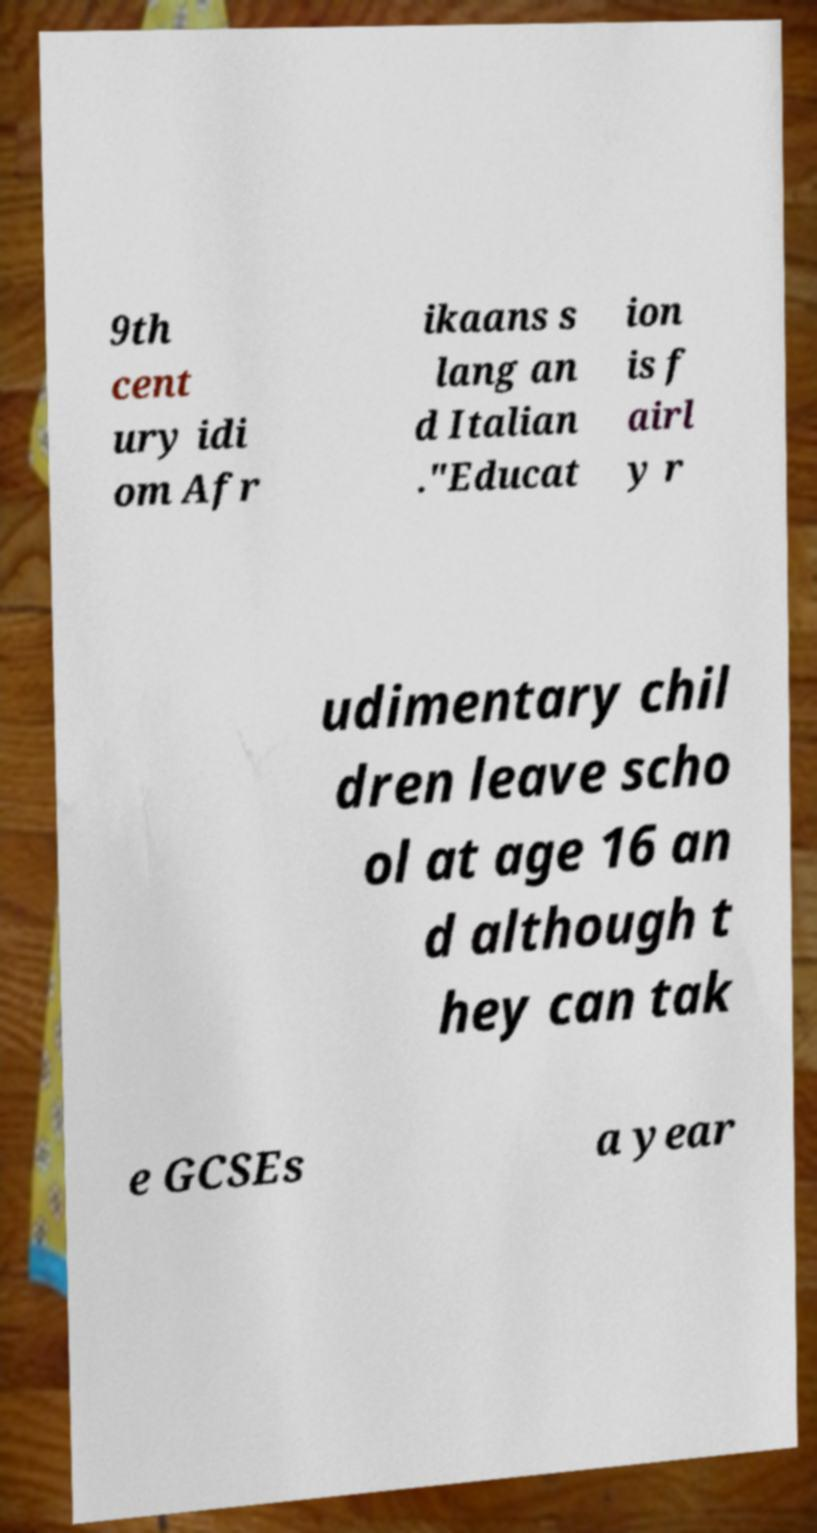I need the written content from this picture converted into text. Can you do that? 9th cent ury idi om Afr ikaans s lang an d Italian ."Educat ion is f airl y r udimentary chil dren leave scho ol at age 16 an d although t hey can tak e GCSEs a year 